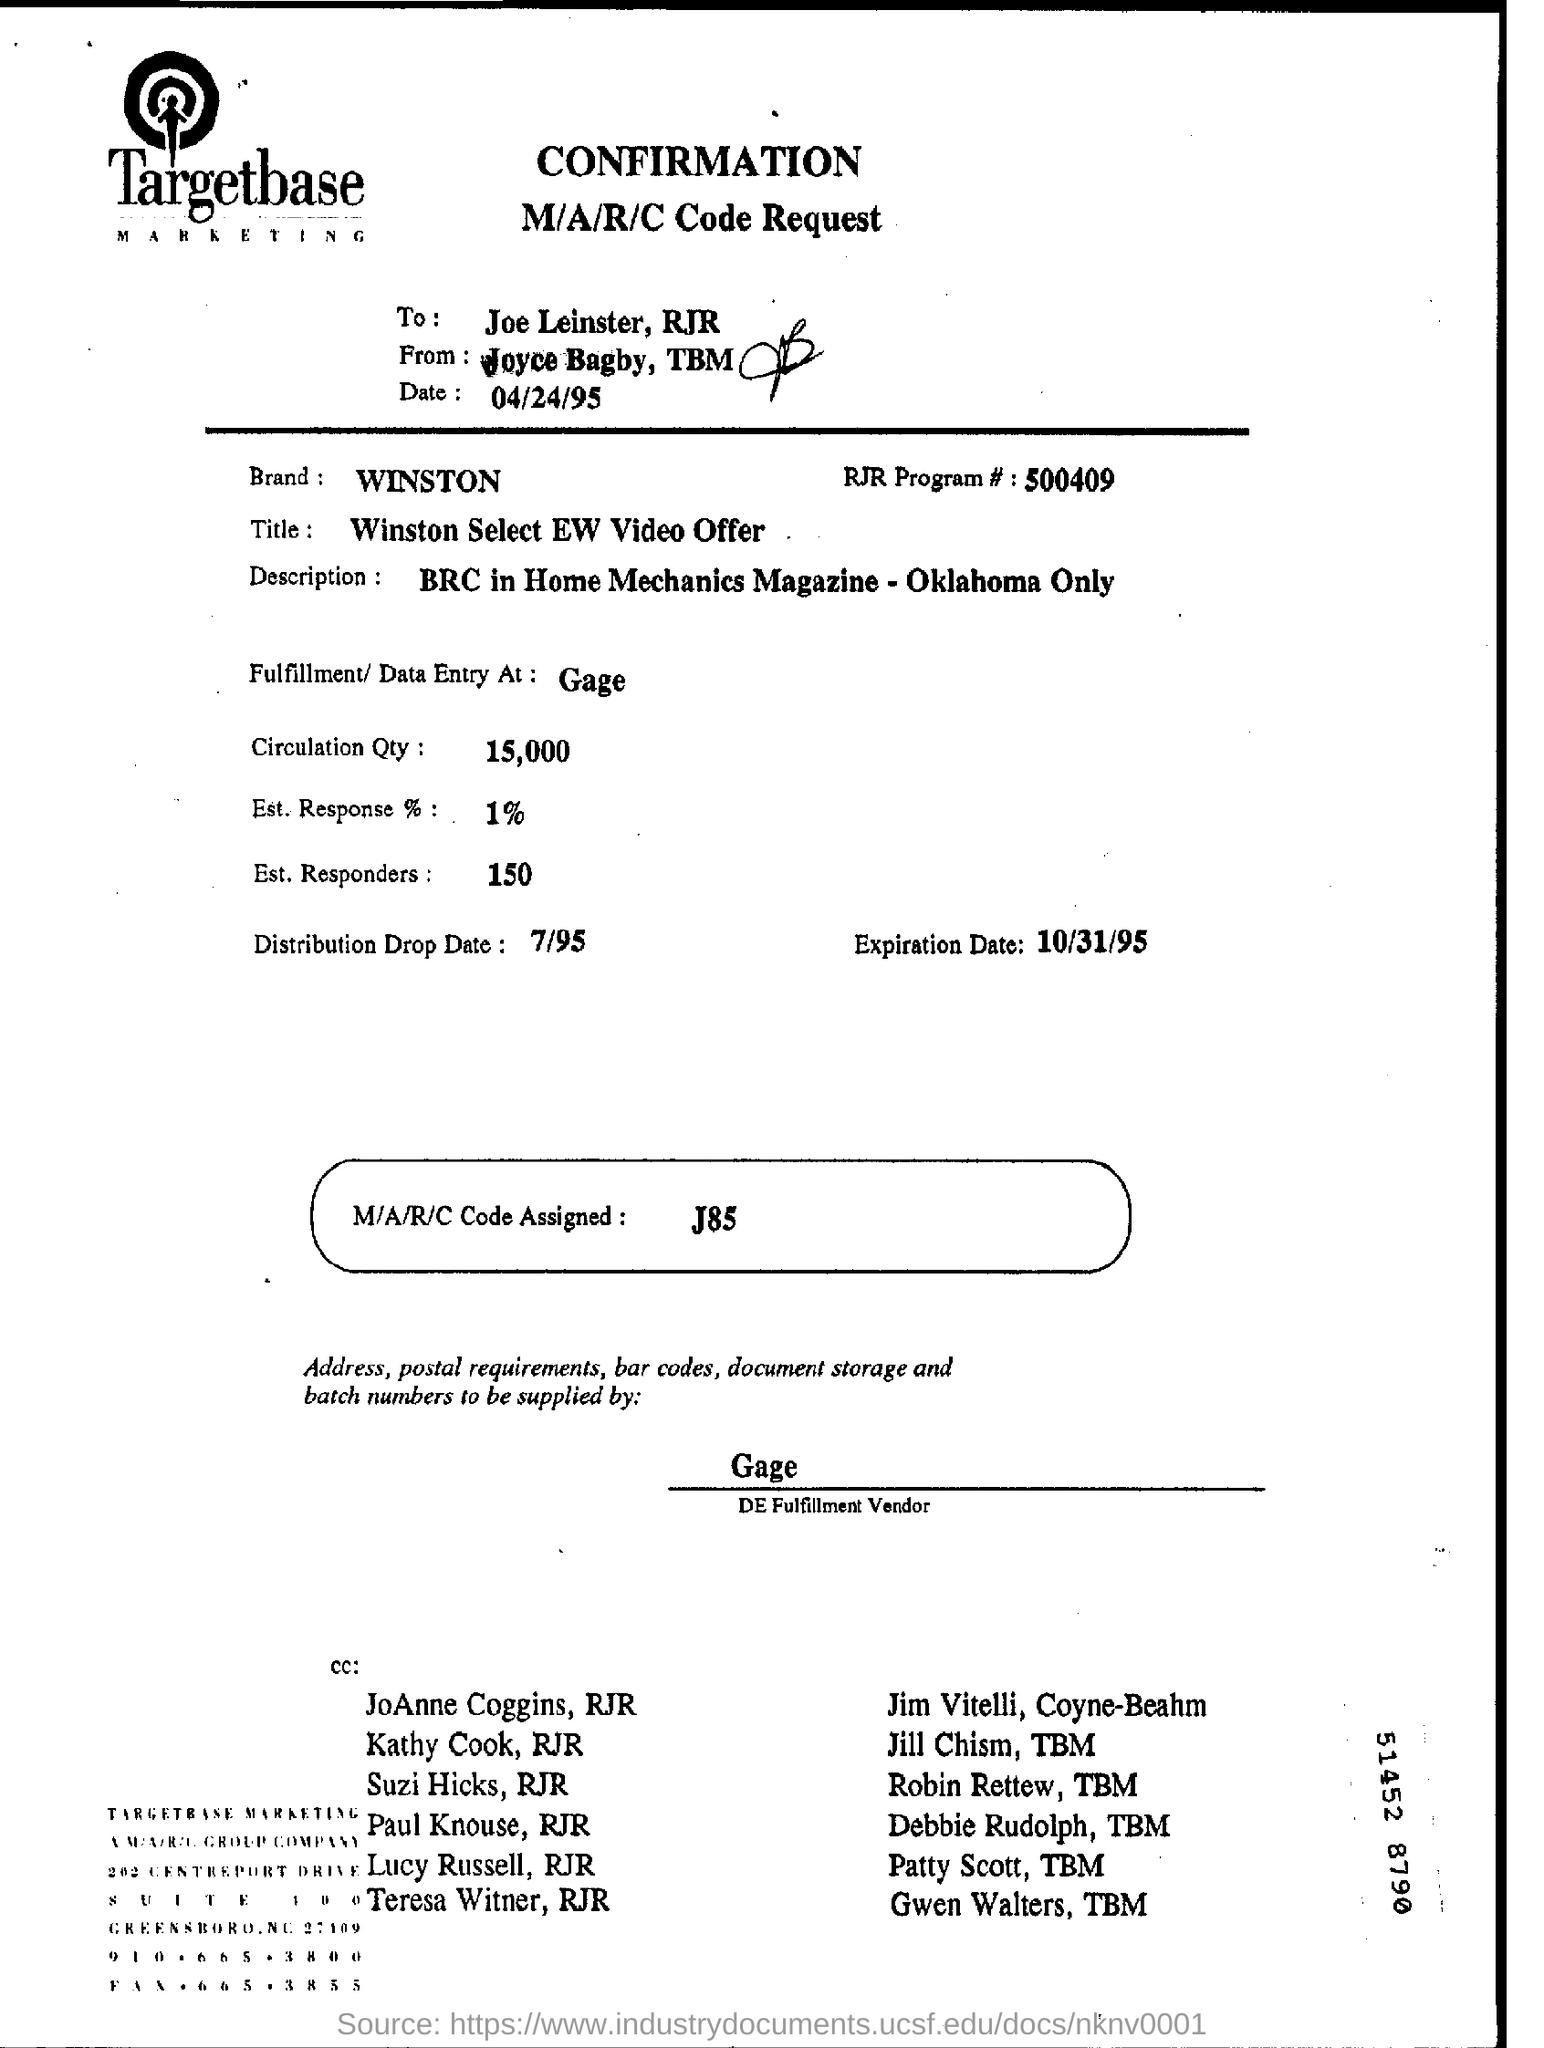Draw attention to some important aspects in this diagram. The circulation quantity is 15,000. The name of the DE fulfillment vendor is Gage. The expiration date is 10/31/95. The brand mentioned is Winston. The code request is directed to Joe Leinster. 